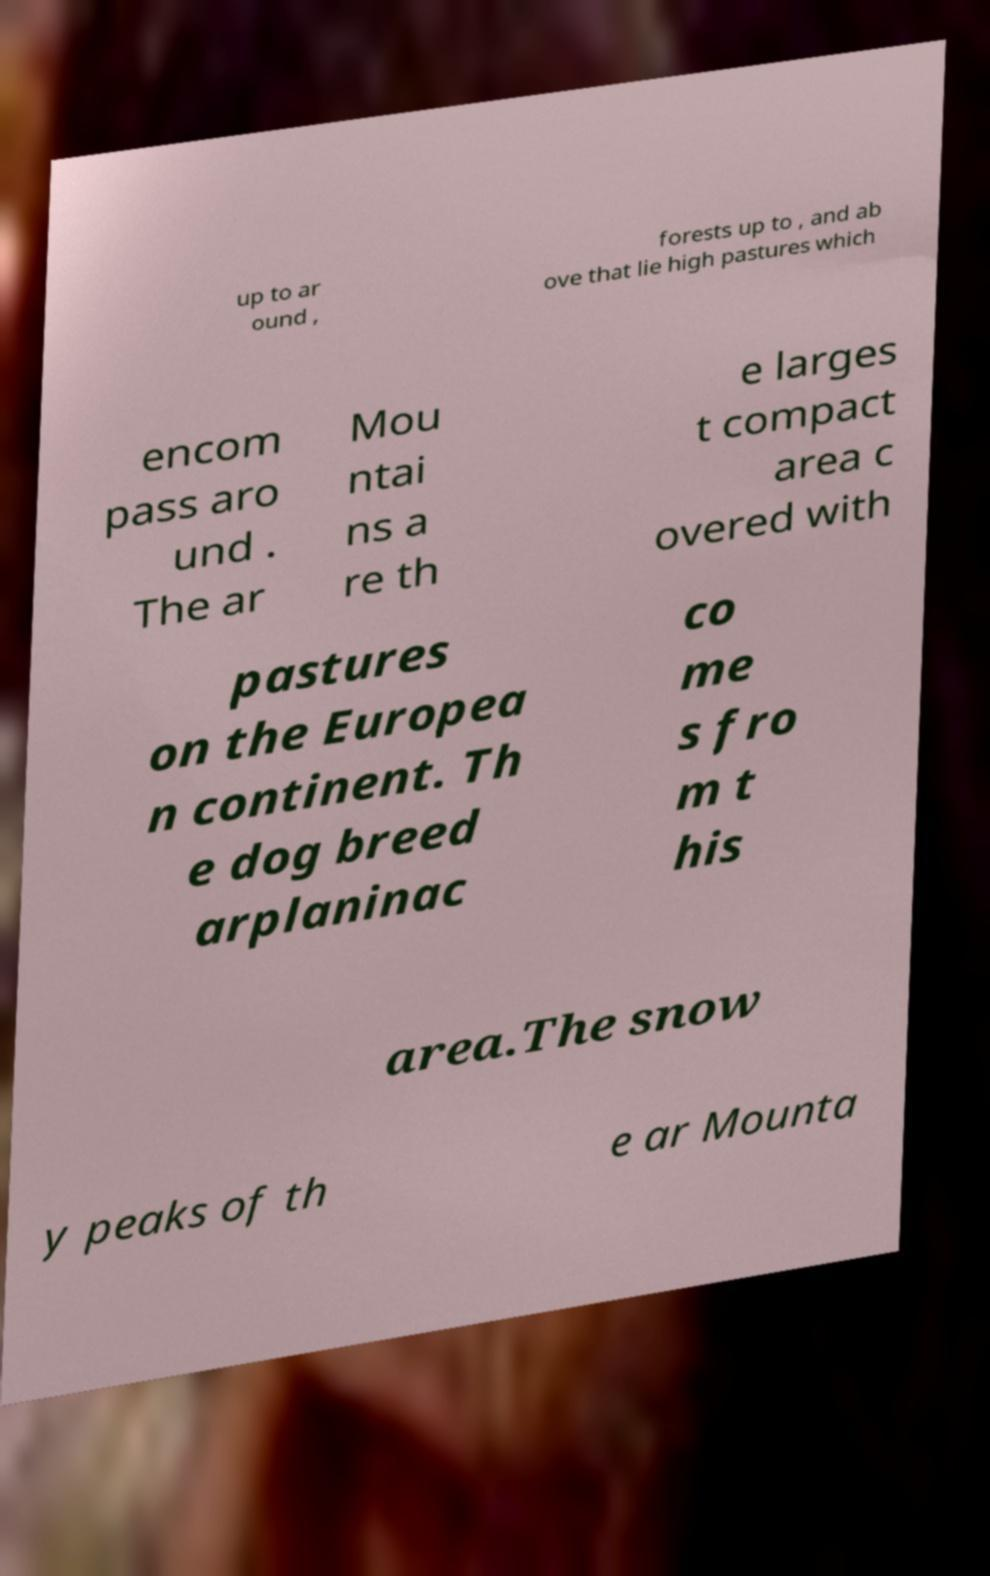For documentation purposes, I need the text within this image transcribed. Could you provide that? up to ar ound , forests up to , and ab ove that lie high pastures which encom pass aro und . The ar Mou ntai ns a re th e larges t compact area c overed with pastures on the Europea n continent. Th e dog breed arplaninac co me s fro m t his area.The snow y peaks of th e ar Mounta 